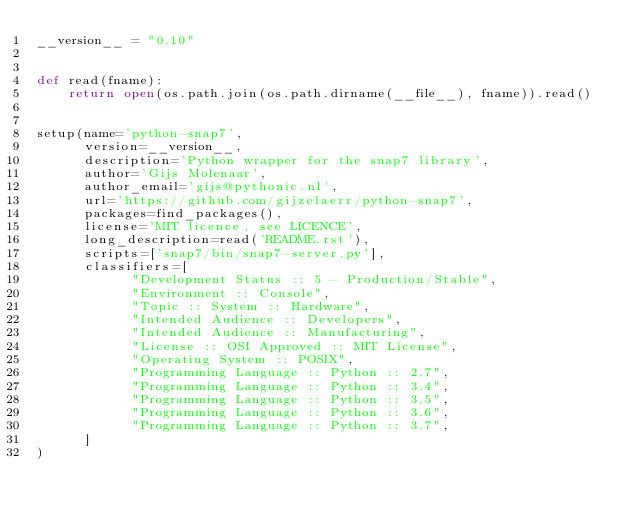<code> <loc_0><loc_0><loc_500><loc_500><_Python_>__version__ = "0.10"


def read(fname):
    return open(os.path.join(os.path.dirname(__file__), fname)).read()


setup(name='python-snap7',
      version=__version__,
      description='Python wrapper for the snap7 library',
      author='Gijs Molenaar',
      author_email='gijs@pythonic.nl',
      url='https://github.com/gijzelaerr/python-snap7',
      packages=find_packages(),
      license='MIT licence, see LICENCE',
      long_description=read('README.rst'),
      scripts=['snap7/bin/snap7-server.py'],
      classifiers=[
            "Development Status :: 5 - Production/Stable",
            "Environment :: Console",
            "Topic :: System :: Hardware",
            "Intended Audience :: Developers",
            "Intended Audience :: Manufacturing",
            "License :: OSI Approved :: MIT License",
            "Operating System :: POSIX",
            "Programming Language :: Python :: 2.7",
            "Programming Language :: Python :: 3.4",
            "Programming Language :: Python :: 3.5",
            "Programming Language :: Python :: 3.6",
            "Programming Language :: Python :: 3.7",
      ]
)
</code> 